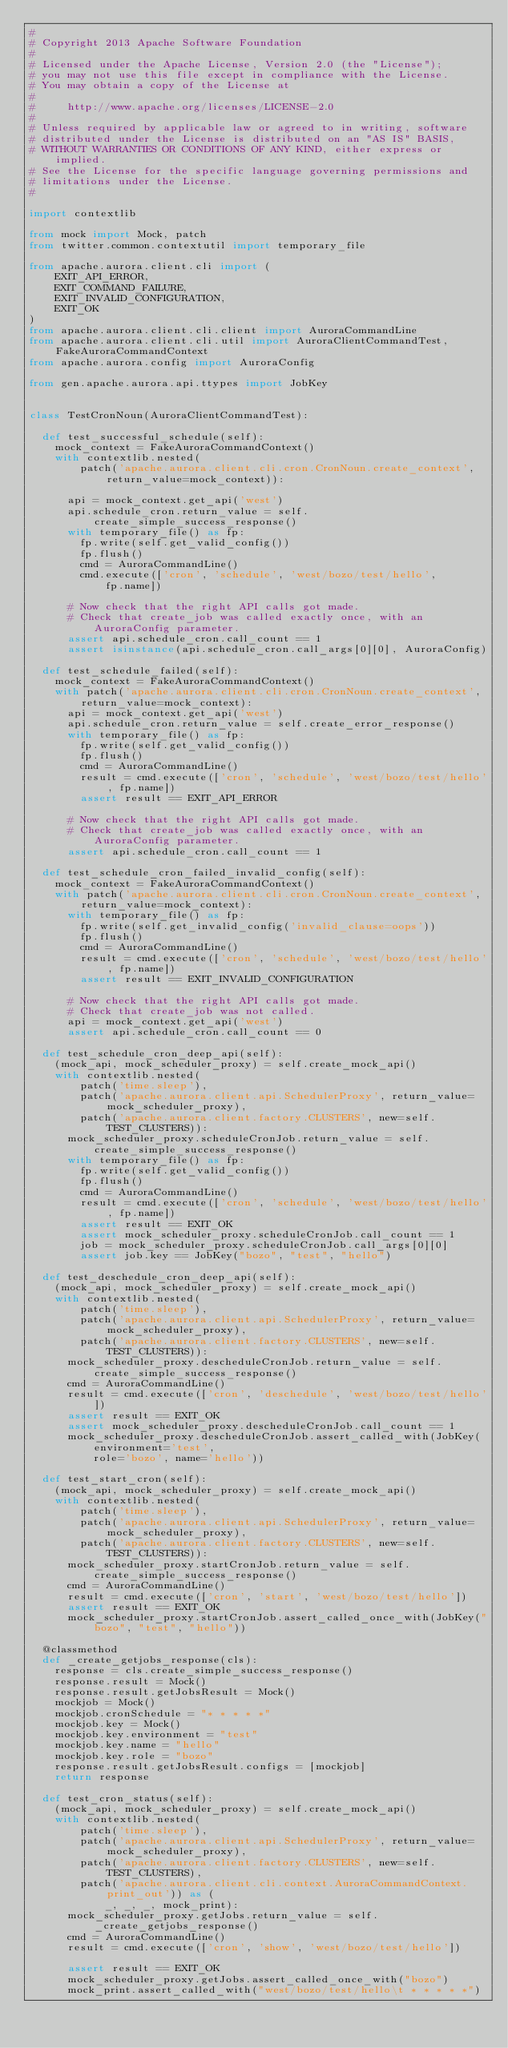<code> <loc_0><loc_0><loc_500><loc_500><_Python_>#
# Copyright 2013 Apache Software Foundation
#
# Licensed under the Apache License, Version 2.0 (the "License");
# you may not use this file except in compliance with the License.
# You may obtain a copy of the License at
#
#     http://www.apache.org/licenses/LICENSE-2.0
#
# Unless required by applicable law or agreed to in writing, software
# distributed under the License is distributed on an "AS IS" BASIS,
# WITHOUT WARRANTIES OR CONDITIONS OF ANY KIND, either express or implied.
# See the License for the specific language governing permissions and
# limitations under the License.
#

import contextlib

from mock import Mock, patch
from twitter.common.contextutil import temporary_file

from apache.aurora.client.cli import (
    EXIT_API_ERROR,
    EXIT_COMMAND_FAILURE,
    EXIT_INVALID_CONFIGURATION,
    EXIT_OK
)
from apache.aurora.client.cli.client import AuroraCommandLine
from apache.aurora.client.cli.util import AuroraClientCommandTest, FakeAuroraCommandContext
from apache.aurora.config import AuroraConfig

from gen.apache.aurora.api.ttypes import JobKey


class TestCronNoun(AuroraClientCommandTest):

  def test_successful_schedule(self):
    mock_context = FakeAuroraCommandContext()
    with contextlib.nested(
        patch('apache.aurora.client.cli.cron.CronNoun.create_context', return_value=mock_context)):

      api = mock_context.get_api('west')
      api.schedule_cron.return_value = self.create_simple_success_response()
      with temporary_file() as fp:
        fp.write(self.get_valid_config())
        fp.flush()
        cmd = AuroraCommandLine()
        cmd.execute(['cron', 'schedule', 'west/bozo/test/hello',
            fp.name])

      # Now check that the right API calls got made.
      # Check that create_job was called exactly once, with an AuroraConfig parameter.
      assert api.schedule_cron.call_count == 1
      assert isinstance(api.schedule_cron.call_args[0][0], AuroraConfig)

  def test_schedule_failed(self):
    mock_context = FakeAuroraCommandContext()
    with patch('apache.aurora.client.cli.cron.CronNoun.create_context', return_value=mock_context):
      api = mock_context.get_api('west')
      api.schedule_cron.return_value = self.create_error_response()
      with temporary_file() as fp:
        fp.write(self.get_valid_config())
        fp.flush()
        cmd = AuroraCommandLine()
        result = cmd.execute(['cron', 'schedule', 'west/bozo/test/hello', fp.name])
        assert result == EXIT_API_ERROR

      # Now check that the right API calls got made.
      # Check that create_job was called exactly once, with an AuroraConfig parameter.
      assert api.schedule_cron.call_count == 1

  def test_schedule_cron_failed_invalid_config(self):
    mock_context = FakeAuroraCommandContext()
    with patch('apache.aurora.client.cli.cron.CronNoun.create_context', return_value=mock_context):
      with temporary_file() as fp:
        fp.write(self.get_invalid_config('invalid_clause=oops'))
        fp.flush()
        cmd = AuroraCommandLine()
        result = cmd.execute(['cron', 'schedule', 'west/bozo/test/hello', fp.name])
        assert result == EXIT_INVALID_CONFIGURATION

      # Now check that the right API calls got made.
      # Check that create_job was not called.
      api = mock_context.get_api('west')
      assert api.schedule_cron.call_count == 0

  def test_schedule_cron_deep_api(self):
    (mock_api, mock_scheduler_proxy) = self.create_mock_api()
    with contextlib.nested(
        patch('time.sleep'),
        patch('apache.aurora.client.api.SchedulerProxy', return_value=mock_scheduler_proxy),
        patch('apache.aurora.client.factory.CLUSTERS', new=self.TEST_CLUSTERS)):
      mock_scheduler_proxy.scheduleCronJob.return_value = self.create_simple_success_response()
      with temporary_file() as fp:
        fp.write(self.get_valid_config())
        fp.flush()
        cmd = AuroraCommandLine()
        result = cmd.execute(['cron', 'schedule', 'west/bozo/test/hello', fp.name])
        assert result == EXIT_OK
        assert mock_scheduler_proxy.scheduleCronJob.call_count == 1
        job = mock_scheduler_proxy.scheduleCronJob.call_args[0][0]
        assert job.key == JobKey("bozo", "test", "hello")

  def test_deschedule_cron_deep_api(self):
    (mock_api, mock_scheduler_proxy) = self.create_mock_api()
    with contextlib.nested(
        patch('time.sleep'),
        patch('apache.aurora.client.api.SchedulerProxy', return_value=mock_scheduler_proxy),
        patch('apache.aurora.client.factory.CLUSTERS', new=self.TEST_CLUSTERS)):
      mock_scheduler_proxy.descheduleCronJob.return_value = self.create_simple_success_response()
      cmd = AuroraCommandLine()
      result = cmd.execute(['cron', 'deschedule', 'west/bozo/test/hello'])
      assert result == EXIT_OK
      assert mock_scheduler_proxy.descheduleCronJob.call_count == 1
      mock_scheduler_proxy.descheduleCronJob.assert_called_with(JobKey(environment='test',
          role='bozo', name='hello'))

  def test_start_cron(self):
    (mock_api, mock_scheduler_proxy) = self.create_mock_api()
    with contextlib.nested(
        patch('time.sleep'),
        patch('apache.aurora.client.api.SchedulerProxy', return_value=mock_scheduler_proxy),
        patch('apache.aurora.client.factory.CLUSTERS', new=self.TEST_CLUSTERS)):
      mock_scheduler_proxy.startCronJob.return_value = self.create_simple_success_response()
      cmd = AuroraCommandLine()
      result = cmd.execute(['cron', 'start', 'west/bozo/test/hello'])
      assert result == EXIT_OK
      mock_scheduler_proxy.startCronJob.assert_called_once_with(JobKey("bozo", "test", "hello"))

  @classmethod
  def _create_getjobs_response(cls):
    response = cls.create_simple_success_response()
    response.result = Mock()
    response.result.getJobsResult = Mock()
    mockjob = Mock()
    mockjob.cronSchedule = "* * * * *"
    mockjob.key = Mock()
    mockjob.key.environment = "test"
    mockjob.key.name = "hello"
    mockjob.key.role = "bozo"
    response.result.getJobsResult.configs = [mockjob]
    return response

  def test_cron_status(self):
    (mock_api, mock_scheduler_proxy) = self.create_mock_api()
    with contextlib.nested(
        patch('time.sleep'),
        patch('apache.aurora.client.api.SchedulerProxy', return_value=mock_scheduler_proxy),
        patch('apache.aurora.client.factory.CLUSTERS', new=self.TEST_CLUSTERS),
        patch('apache.aurora.client.cli.context.AuroraCommandContext.print_out')) as (
            _, _, _, mock_print):
      mock_scheduler_proxy.getJobs.return_value = self._create_getjobs_response()
      cmd = AuroraCommandLine()
      result = cmd.execute(['cron', 'show', 'west/bozo/test/hello'])

      assert result == EXIT_OK
      mock_scheduler_proxy.getJobs.assert_called_once_with("bozo")
      mock_print.assert_called_with("west/bozo/test/hello\t * * * * *")
</code> 